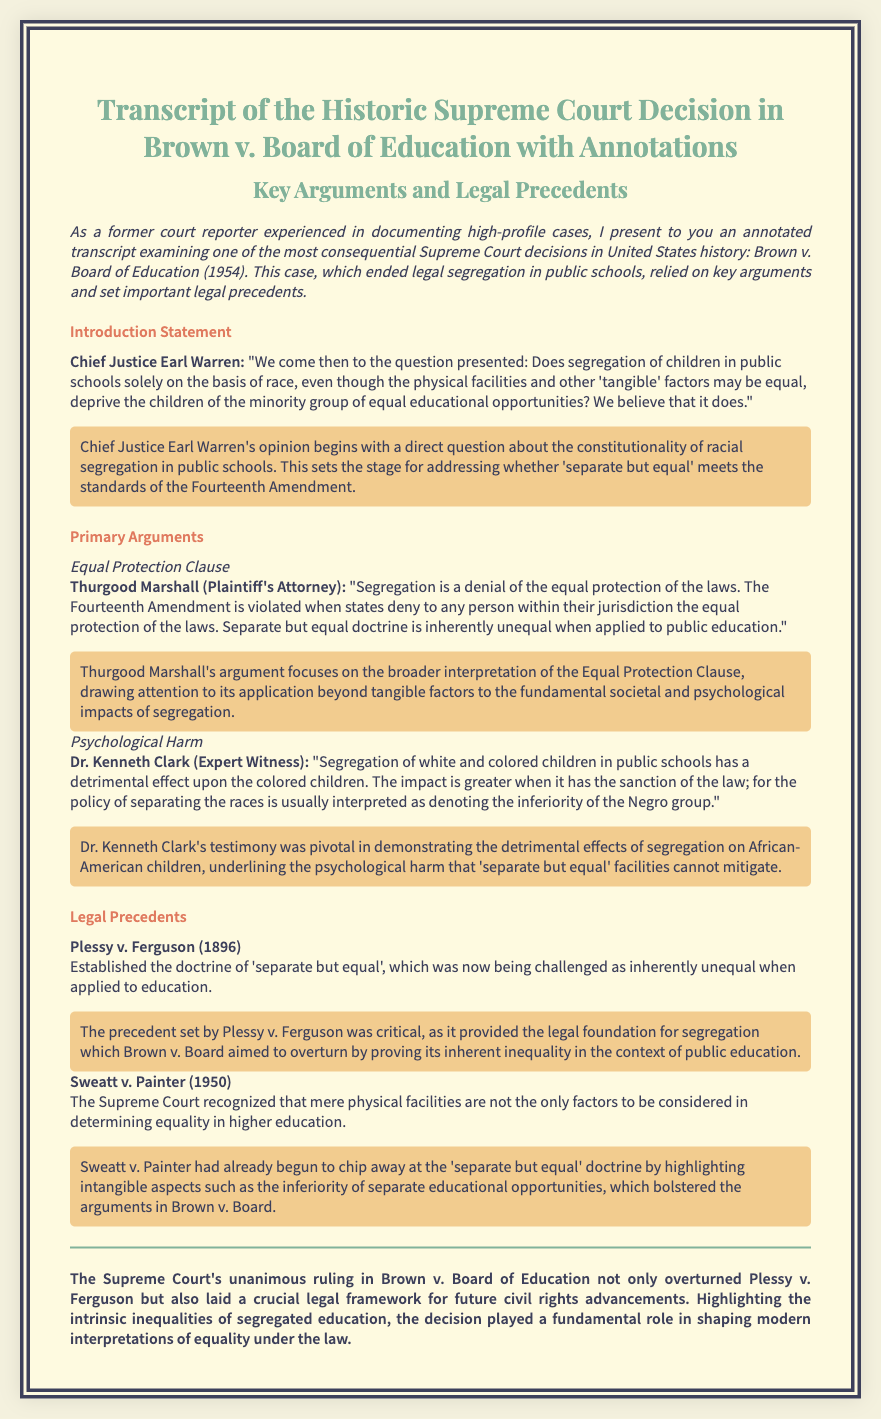What is the title of the document? The title of the document is presented prominently, capturing the essence of the Supreme Court decision and its importance.
Answer: Transcript of the Historic Supreme Court Decision in Brown v. Board of Education with Annotations Who delivered the introduction statement? The introduction statement is attributed to the Chief Justice, who plays a key role in framing the discussion of the case.
Answer: Chief Justice Earl Warren What year was the Brown v. Board of Education decision made? The year when the decision was made is fundamental to understanding the historical context of the case.
Answer: 1954 What doctrine did the case seek to overturn? The key legal doctrine that was being challenged in this case is pivotal to understanding its significance and impact on civil rights law.
Answer: separate but equal Which expert witness provided testimony about psychological harm? The expert witness's contributions are significant in terms of illustrating the broader impacts of segregation, thus enhancing the case's arguments.
Answer: Dr. Kenneth Clark What previous case established the 'separate but equal' doctrine? This previous case is crucial for understanding the legal foundation that Brown v. Board aimed to overturn through its arguments.
Answer: Plessy v. Ferguson What was the Supreme Court's ruling in Brown v. Board? The final outcome of the case is critical for understanding its impact on civil rights and education in the United States.
Answer: unanimous ruling What concept did Thurgood Marshall emphasize in his argument? The emphasis placed in Marshall's argument is central to the legal reasoning driving the case forward and its outcome.
Answer: Equal Protection Clause 